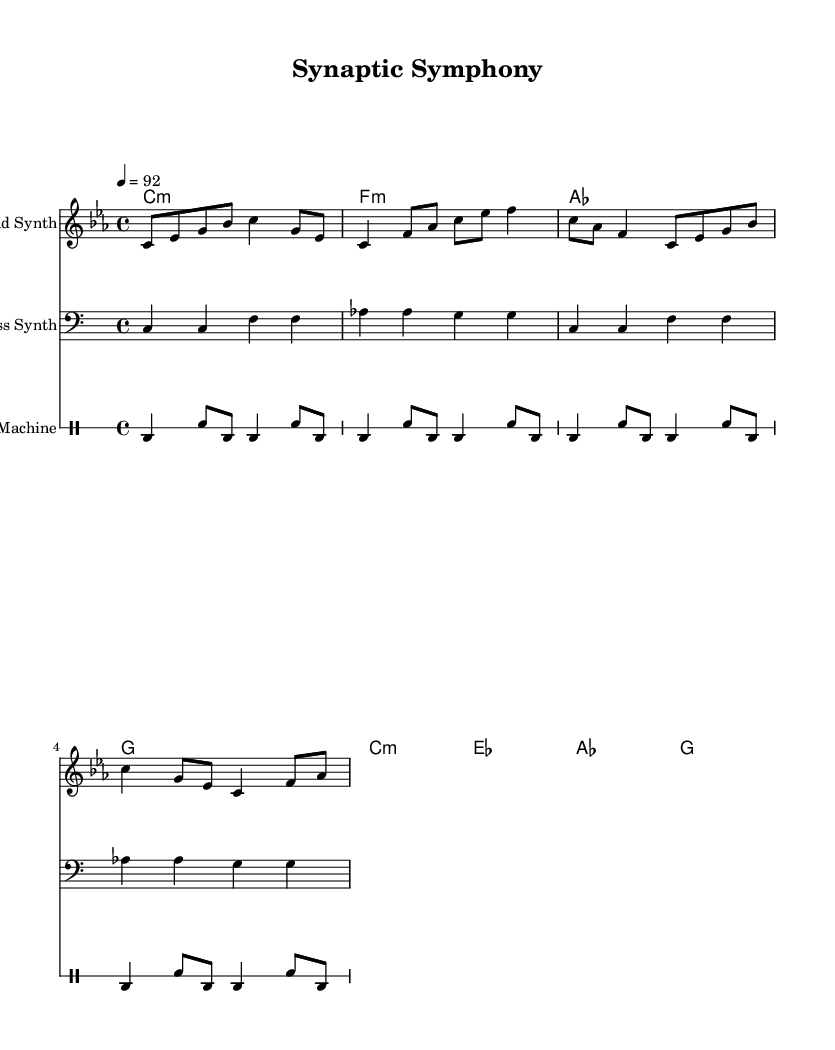What is the key signature of this music? The key signature is C minor, indicated by three flats in the key signature on the staff.
Answer: C minor What is the time signature of this piece? The time signature is shown as a "4/4" in the beginning of the score, indicating four beats per measure.
Answer: 4/4 What is the tempo marking for the piece? The tempo is indicated at the beginning as "4 = 92," meaning there are 92 beats per minute.
Answer: 92 How many measures are in the melody? By counting the segments separated by bar lines in the melody section, there are four measures total in the melody.
Answer: 4 What instrument plays the drum patterns? The score specifies the drum patterns to be played on a "Drum Machine" as indicated at the beginning of the drum staff.
Answer: Drum Machine Which chord follows the A-flat chord in the harmonic progression? In the chord progression, after "as" (A-flat), the next chord is "g" (G major), as shown in the harmonic line.
Answer: g What clef is used for the bass line? The bass line is written in the bass clef, which is indicated at the beginning of the bass line staff.
Answer: Bass clef 